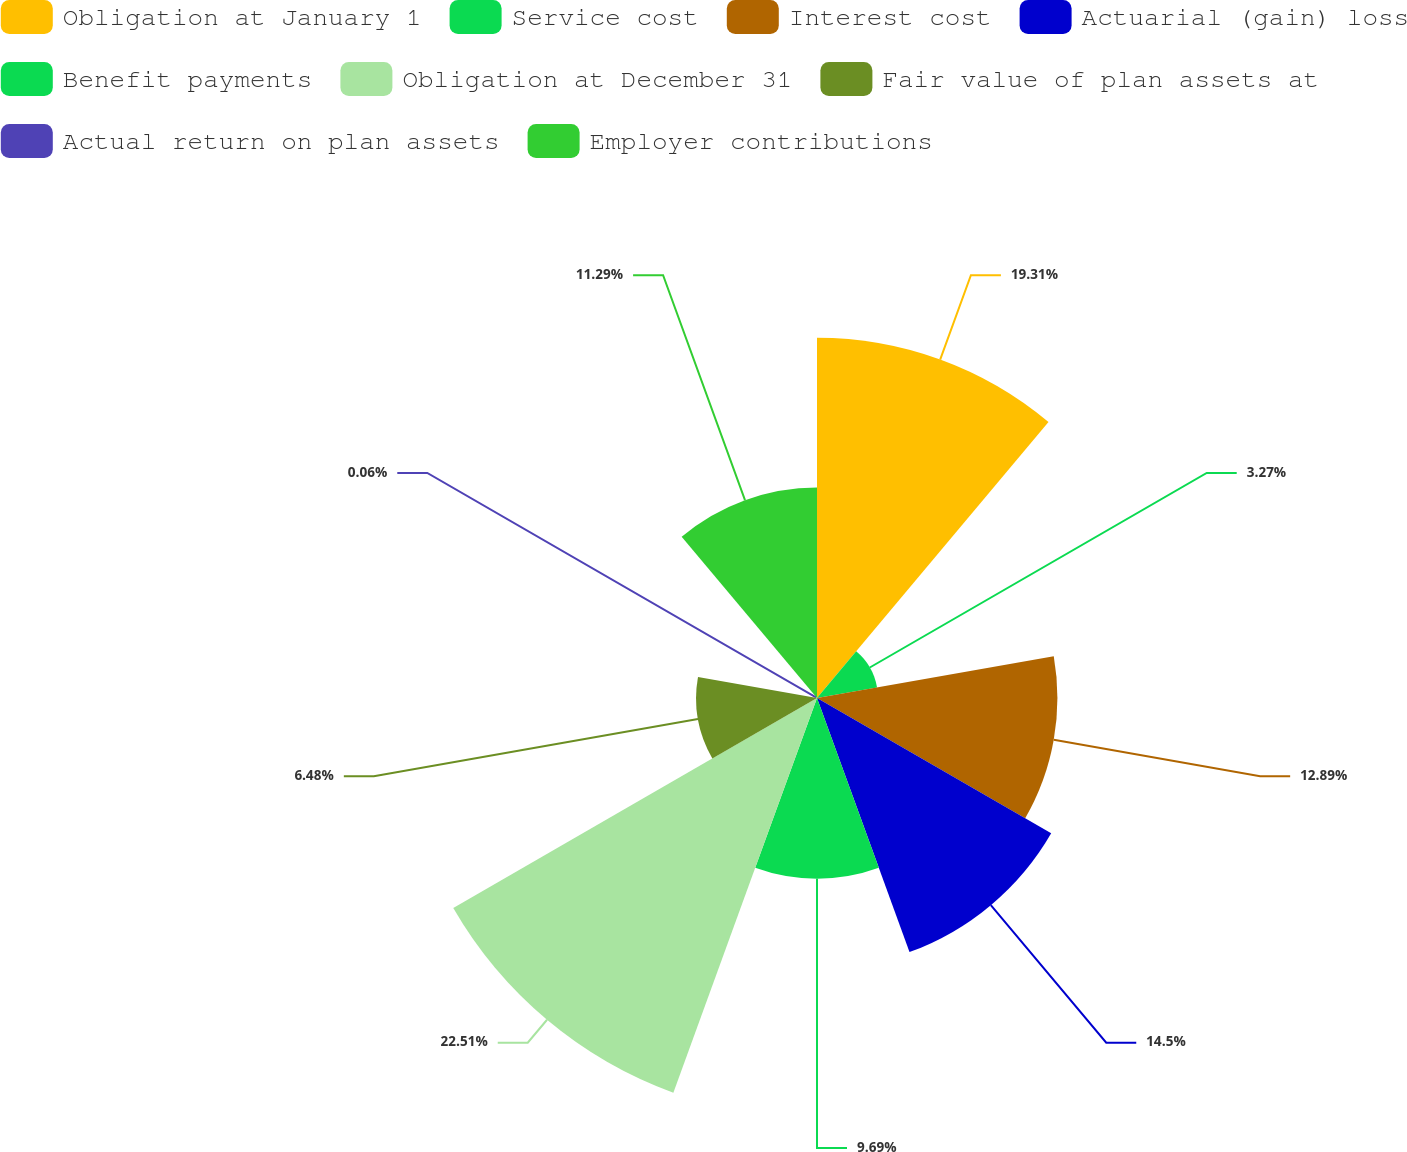<chart> <loc_0><loc_0><loc_500><loc_500><pie_chart><fcel>Obligation at January 1<fcel>Service cost<fcel>Interest cost<fcel>Actuarial (gain) loss<fcel>Benefit payments<fcel>Obligation at December 31<fcel>Fair value of plan assets at<fcel>Actual return on plan assets<fcel>Employer contributions<nl><fcel>19.31%<fcel>3.27%<fcel>12.89%<fcel>14.5%<fcel>9.69%<fcel>22.52%<fcel>6.48%<fcel>0.06%<fcel>11.29%<nl></chart> 